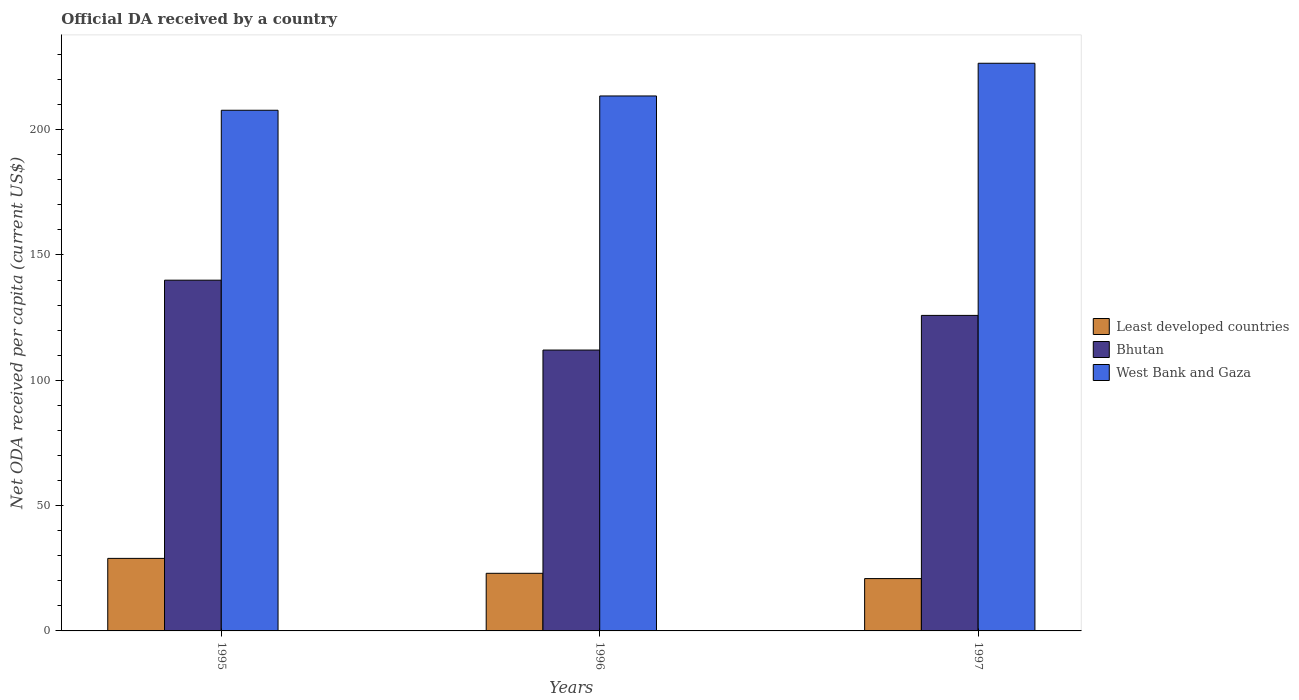Are the number of bars on each tick of the X-axis equal?
Your answer should be compact. Yes. How many bars are there on the 2nd tick from the left?
Your answer should be very brief. 3. How many bars are there on the 3rd tick from the right?
Provide a succinct answer. 3. What is the label of the 2nd group of bars from the left?
Make the answer very short. 1996. In how many cases, is the number of bars for a given year not equal to the number of legend labels?
Offer a terse response. 0. What is the ODA received in in Bhutan in 1995?
Offer a terse response. 139.95. Across all years, what is the maximum ODA received in in Least developed countries?
Your answer should be compact. 28.94. Across all years, what is the minimum ODA received in in West Bank and Gaza?
Provide a succinct answer. 207.75. In which year was the ODA received in in Least developed countries maximum?
Your answer should be very brief. 1995. What is the total ODA received in in Least developed countries in the graph?
Keep it short and to the point. 72.81. What is the difference between the ODA received in in Bhutan in 1995 and that in 1997?
Offer a terse response. 14.06. What is the difference between the ODA received in in West Bank and Gaza in 1997 and the ODA received in in Least developed countries in 1996?
Give a very brief answer. 203.51. What is the average ODA received in in Bhutan per year?
Ensure brevity in your answer.  125.97. In the year 1995, what is the difference between the ODA received in in Least developed countries and ODA received in in West Bank and Gaza?
Ensure brevity in your answer.  -178.81. What is the ratio of the ODA received in in Bhutan in 1995 to that in 1996?
Your response must be concise. 1.25. Is the ODA received in in Bhutan in 1995 less than that in 1997?
Provide a succinct answer. No. What is the difference between the highest and the second highest ODA received in in Least developed countries?
Offer a very short reply. 5.95. What is the difference between the highest and the lowest ODA received in in West Bank and Gaza?
Provide a short and direct response. 18.75. In how many years, is the ODA received in in Least developed countries greater than the average ODA received in in Least developed countries taken over all years?
Your answer should be very brief. 1. Is the sum of the ODA received in in West Bank and Gaza in 1996 and 1997 greater than the maximum ODA received in in Least developed countries across all years?
Offer a very short reply. Yes. What does the 3rd bar from the left in 1995 represents?
Keep it short and to the point. West Bank and Gaza. What does the 1st bar from the right in 1995 represents?
Provide a succinct answer. West Bank and Gaza. Are all the bars in the graph horizontal?
Provide a short and direct response. No. What is the difference between two consecutive major ticks on the Y-axis?
Give a very brief answer. 50. Are the values on the major ticks of Y-axis written in scientific E-notation?
Provide a short and direct response. No. Does the graph contain any zero values?
Your answer should be compact. No. Does the graph contain grids?
Give a very brief answer. No. Where does the legend appear in the graph?
Give a very brief answer. Center right. How many legend labels are there?
Provide a succinct answer. 3. What is the title of the graph?
Keep it short and to the point. Official DA received by a country. What is the label or title of the X-axis?
Offer a very short reply. Years. What is the label or title of the Y-axis?
Your answer should be compact. Net ODA received per capita (current US$). What is the Net ODA received per capita (current US$) of Least developed countries in 1995?
Make the answer very short. 28.94. What is the Net ODA received per capita (current US$) in Bhutan in 1995?
Provide a short and direct response. 139.95. What is the Net ODA received per capita (current US$) in West Bank and Gaza in 1995?
Offer a terse response. 207.75. What is the Net ODA received per capita (current US$) in Least developed countries in 1996?
Your answer should be compact. 22.99. What is the Net ODA received per capita (current US$) in Bhutan in 1996?
Your response must be concise. 112.07. What is the Net ODA received per capita (current US$) of West Bank and Gaza in 1996?
Offer a very short reply. 213.45. What is the Net ODA received per capita (current US$) of Least developed countries in 1997?
Ensure brevity in your answer.  20.88. What is the Net ODA received per capita (current US$) of Bhutan in 1997?
Offer a terse response. 125.89. What is the Net ODA received per capita (current US$) in West Bank and Gaza in 1997?
Your answer should be very brief. 226.5. Across all years, what is the maximum Net ODA received per capita (current US$) of Least developed countries?
Ensure brevity in your answer.  28.94. Across all years, what is the maximum Net ODA received per capita (current US$) in Bhutan?
Give a very brief answer. 139.95. Across all years, what is the maximum Net ODA received per capita (current US$) in West Bank and Gaza?
Make the answer very short. 226.5. Across all years, what is the minimum Net ODA received per capita (current US$) of Least developed countries?
Give a very brief answer. 20.88. Across all years, what is the minimum Net ODA received per capita (current US$) in Bhutan?
Your response must be concise. 112.07. Across all years, what is the minimum Net ODA received per capita (current US$) in West Bank and Gaza?
Make the answer very short. 207.75. What is the total Net ODA received per capita (current US$) of Least developed countries in the graph?
Ensure brevity in your answer.  72.81. What is the total Net ODA received per capita (current US$) of Bhutan in the graph?
Provide a succinct answer. 377.91. What is the total Net ODA received per capita (current US$) in West Bank and Gaza in the graph?
Provide a short and direct response. 647.7. What is the difference between the Net ODA received per capita (current US$) in Least developed countries in 1995 and that in 1996?
Provide a succinct answer. 5.95. What is the difference between the Net ODA received per capita (current US$) in Bhutan in 1995 and that in 1996?
Your response must be concise. 27.88. What is the difference between the Net ODA received per capita (current US$) in West Bank and Gaza in 1995 and that in 1996?
Give a very brief answer. -5.7. What is the difference between the Net ODA received per capita (current US$) in Least developed countries in 1995 and that in 1997?
Give a very brief answer. 8.06. What is the difference between the Net ODA received per capita (current US$) in Bhutan in 1995 and that in 1997?
Provide a succinct answer. 14.06. What is the difference between the Net ODA received per capita (current US$) in West Bank and Gaza in 1995 and that in 1997?
Make the answer very short. -18.75. What is the difference between the Net ODA received per capita (current US$) of Least developed countries in 1996 and that in 1997?
Make the answer very short. 2.11. What is the difference between the Net ODA received per capita (current US$) in Bhutan in 1996 and that in 1997?
Your response must be concise. -13.83. What is the difference between the Net ODA received per capita (current US$) in West Bank and Gaza in 1996 and that in 1997?
Ensure brevity in your answer.  -13.05. What is the difference between the Net ODA received per capita (current US$) of Least developed countries in 1995 and the Net ODA received per capita (current US$) of Bhutan in 1996?
Ensure brevity in your answer.  -83.13. What is the difference between the Net ODA received per capita (current US$) in Least developed countries in 1995 and the Net ODA received per capita (current US$) in West Bank and Gaza in 1996?
Offer a terse response. -184.51. What is the difference between the Net ODA received per capita (current US$) of Bhutan in 1995 and the Net ODA received per capita (current US$) of West Bank and Gaza in 1996?
Provide a short and direct response. -73.5. What is the difference between the Net ODA received per capita (current US$) of Least developed countries in 1995 and the Net ODA received per capita (current US$) of Bhutan in 1997?
Give a very brief answer. -96.95. What is the difference between the Net ODA received per capita (current US$) in Least developed countries in 1995 and the Net ODA received per capita (current US$) in West Bank and Gaza in 1997?
Give a very brief answer. -197.56. What is the difference between the Net ODA received per capita (current US$) in Bhutan in 1995 and the Net ODA received per capita (current US$) in West Bank and Gaza in 1997?
Make the answer very short. -86.55. What is the difference between the Net ODA received per capita (current US$) of Least developed countries in 1996 and the Net ODA received per capita (current US$) of Bhutan in 1997?
Provide a short and direct response. -102.9. What is the difference between the Net ODA received per capita (current US$) of Least developed countries in 1996 and the Net ODA received per capita (current US$) of West Bank and Gaza in 1997?
Give a very brief answer. -203.51. What is the difference between the Net ODA received per capita (current US$) of Bhutan in 1996 and the Net ODA received per capita (current US$) of West Bank and Gaza in 1997?
Your response must be concise. -114.44. What is the average Net ODA received per capita (current US$) in Least developed countries per year?
Your answer should be compact. 24.27. What is the average Net ODA received per capita (current US$) in Bhutan per year?
Give a very brief answer. 125.97. What is the average Net ODA received per capita (current US$) in West Bank and Gaza per year?
Make the answer very short. 215.9. In the year 1995, what is the difference between the Net ODA received per capita (current US$) in Least developed countries and Net ODA received per capita (current US$) in Bhutan?
Your answer should be compact. -111.01. In the year 1995, what is the difference between the Net ODA received per capita (current US$) in Least developed countries and Net ODA received per capita (current US$) in West Bank and Gaza?
Provide a succinct answer. -178.81. In the year 1995, what is the difference between the Net ODA received per capita (current US$) of Bhutan and Net ODA received per capita (current US$) of West Bank and Gaza?
Offer a terse response. -67.8. In the year 1996, what is the difference between the Net ODA received per capita (current US$) of Least developed countries and Net ODA received per capita (current US$) of Bhutan?
Make the answer very short. -89.08. In the year 1996, what is the difference between the Net ODA received per capita (current US$) of Least developed countries and Net ODA received per capita (current US$) of West Bank and Gaza?
Provide a succinct answer. -190.46. In the year 1996, what is the difference between the Net ODA received per capita (current US$) of Bhutan and Net ODA received per capita (current US$) of West Bank and Gaza?
Offer a terse response. -101.38. In the year 1997, what is the difference between the Net ODA received per capita (current US$) of Least developed countries and Net ODA received per capita (current US$) of Bhutan?
Provide a succinct answer. -105.01. In the year 1997, what is the difference between the Net ODA received per capita (current US$) of Least developed countries and Net ODA received per capita (current US$) of West Bank and Gaza?
Give a very brief answer. -205.62. In the year 1997, what is the difference between the Net ODA received per capita (current US$) of Bhutan and Net ODA received per capita (current US$) of West Bank and Gaza?
Ensure brevity in your answer.  -100.61. What is the ratio of the Net ODA received per capita (current US$) in Least developed countries in 1995 to that in 1996?
Your response must be concise. 1.26. What is the ratio of the Net ODA received per capita (current US$) of Bhutan in 1995 to that in 1996?
Provide a succinct answer. 1.25. What is the ratio of the Net ODA received per capita (current US$) of West Bank and Gaza in 1995 to that in 1996?
Offer a terse response. 0.97. What is the ratio of the Net ODA received per capita (current US$) of Least developed countries in 1995 to that in 1997?
Keep it short and to the point. 1.39. What is the ratio of the Net ODA received per capita (current US$) in Bhutan in 1995 to that in 1997?
Give a very brief answer. 1.11. What is the ratio of the Net ODA received per capita (current US$) of West Bank and Gaza in 1995 to that in 1997?
Provide a succinct answer. 0.92. What is the ratio of the Net ODA received per capita (current US$) of Least developed countries in 1996 to that in 1997?
Provide a short and direct response. 1.1. What is the ratio of the Net ODA received per capita (current US$) in Bhutan in 1996 to that in 1997?
Offer a terse response. 0.89. What is the ratio of the Net ODA received per capita (current US$) of West Bank and Gaza in 1996 to that in 1997?
Provide a succinct answer. 0.94. What is the difference between the highest and the second highest Net ODA received per capita (current US$) of Least developed countries?
Give a very brief answer. 5.95. What is the difference between the highest and the second highest Net ODA received per capita (current US$) in Bhutan?
Keep it short and to the point. 14.06. What is the difference between the highest and the second highest Net ODA received per capita (current US$) of West Bank and Gaza?
Your response must be concise. 13.05. What is the difference between the highest and the lowest Net ODA received per capita (current US$) of Least developed countries?
Give a very brief answer. 8.06. What is the difference between the highest and the lowest Net ODA received per capita (current US$) in Bhutan?
Ensure brevity in your answer.  27.88. What is the difference between the highest and the lowest Net ODA received per capita (current US$) of West Bank and Gaza?
Offer a terse response. 18.75. 